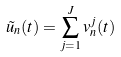Convert formula to latex. <formula><loc_0><loc_0><loc_500><loc_500>\tilde { u } _ { n } ( t ) = \sum _ { j = 1 } ^ { J } v _ { n } ^ { j } ( t )</formula> 